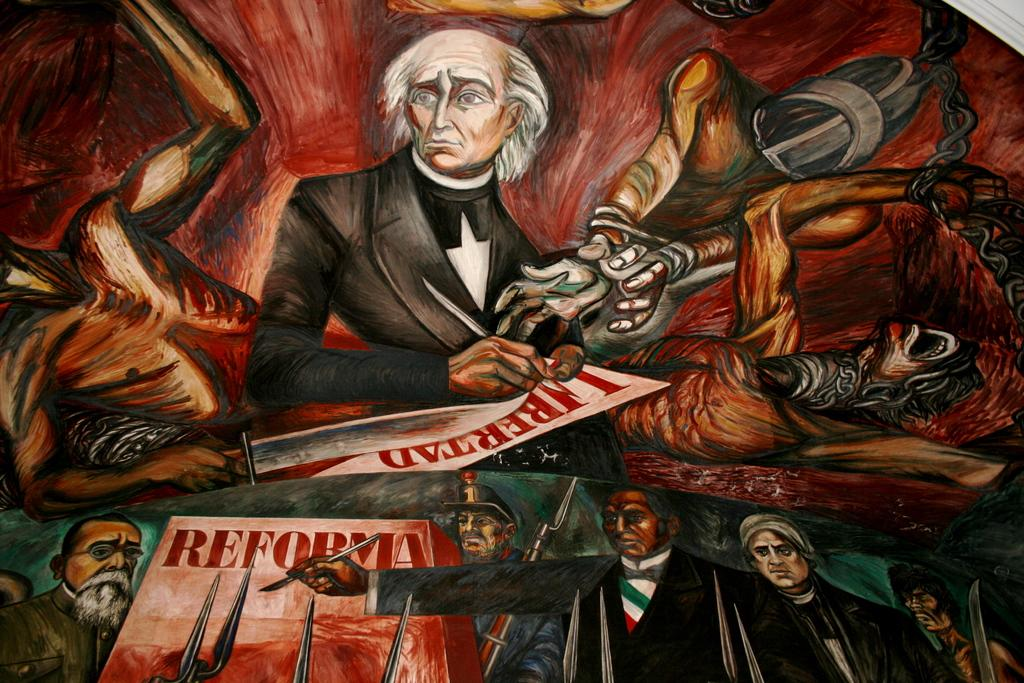<image>
Relay a brief, clear account of the picture shown. A piece of artwork showing a man in a suit and a paper that says reforma. 